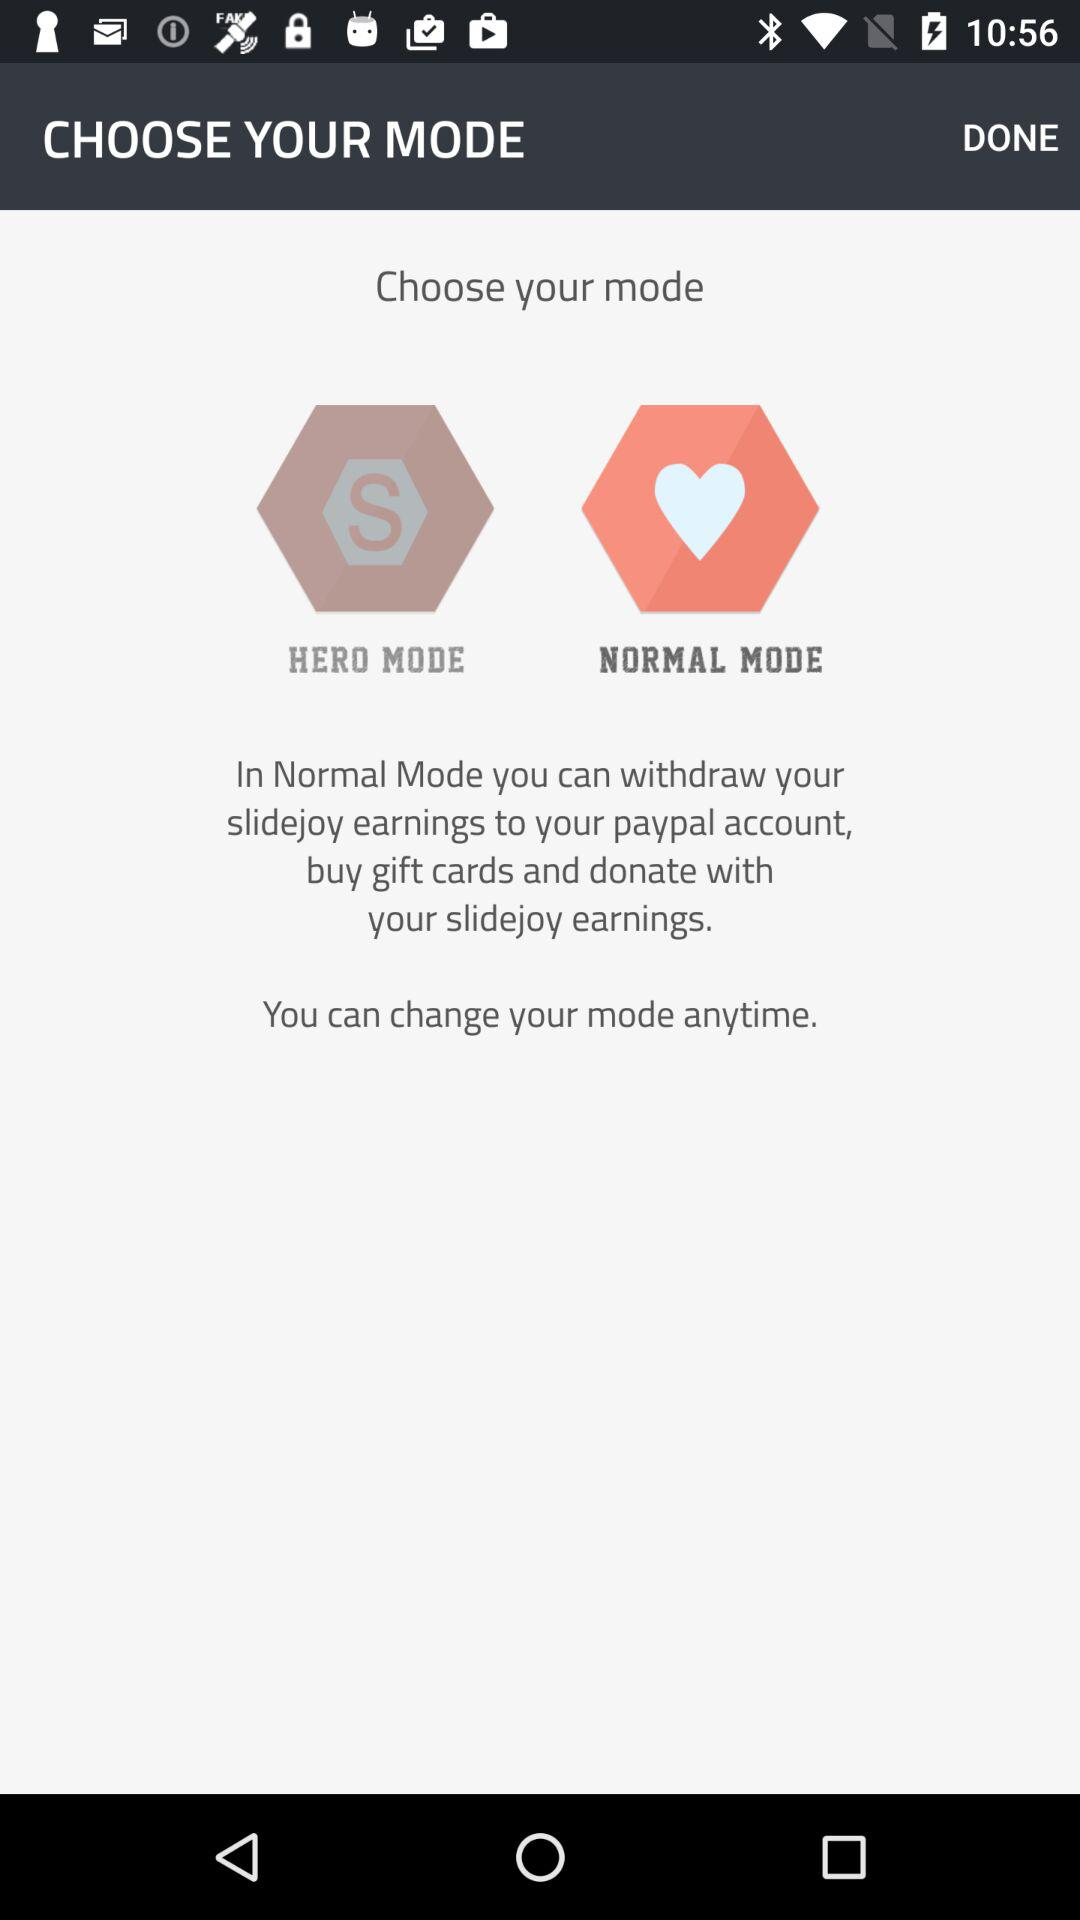How many modes are there in the app?
Answer the question using a single word or phrase. 2 